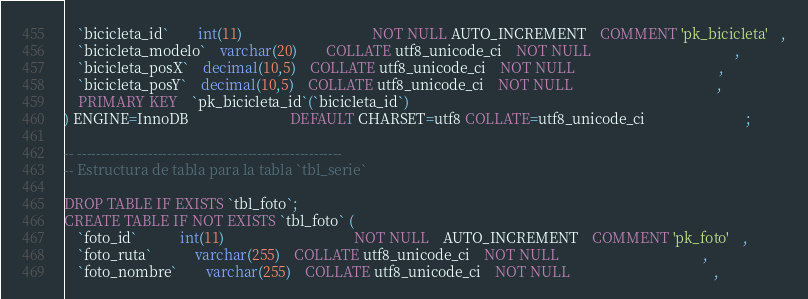<code> <loc_0><loc_0><loc_500><loc_500><_SQL_>	`bicicleta_id`		int(11)									NOT NULL AUTO_INCREMENT	COMMENT 'pk_bicicleta'	,
	`bicicleta_modelo`	varchar(20)		COLLATE utf8_unicode_ci	NOT NULL										,
	`bicicleta_posX`	decimal(10,5)	COLLATE utf8_unicode_ci	NOT NULL 										,
	`bicicleta_posY`	decimal(10,5)	COLLATE utf8_unicode_ci	NOT NULL 										,
	PRIMARY KEY	`pk_bicicleta_id`(`bicicleta_id`)
) ENGINE=InnoDB							DEFAULT CHARSET=utf8 COLLATE=utf8_unicode_ci							;

-- --------------------------------------------------------
-- Estructura de tabla para la tabla `tbl_serie`

DROP TABLE IF EXISTS `tbl_foto`;
CREATE TABLE IF NOT EXISTS `tbl_foto` (
	`foto_id`			int(11)									NOT NULL 	AUTO_INCREMENT	COMMENT 'pk_foto'	,
	`foto_ruta`			varchar(255)	COLLATE utf8_unicode_ci	NOT NULL										,
	`foto_nombre`		varchar(255)	COLLATE utf8_unicode_ci	NOT NULL										,</code> 